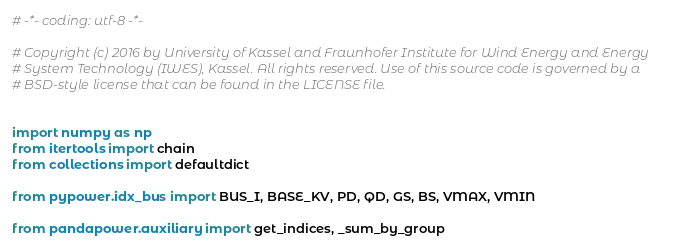<code> <loc_0><loc_0><loc_500><loc_500><_Python_># -*- coding: utf-8 -*-

# Copyright (c) 2016 by University of Kassel and Fraunhofer Institute for Wind Energy and Energy
# System Technology (IWES), Kassel. All rights reserved. Use of this source code is governed by a
# BSD-style license that can be found in the LICENSE file.


import numpy as np
from itertools import chain
from collections import defaultdict

from pypower.idx_bus import BUS_I, BASE_KV, PD, QD, GS, BS, VMAX, VMIN

from pandapower.auxiliary import get_indices, _sum_by_group</code> 